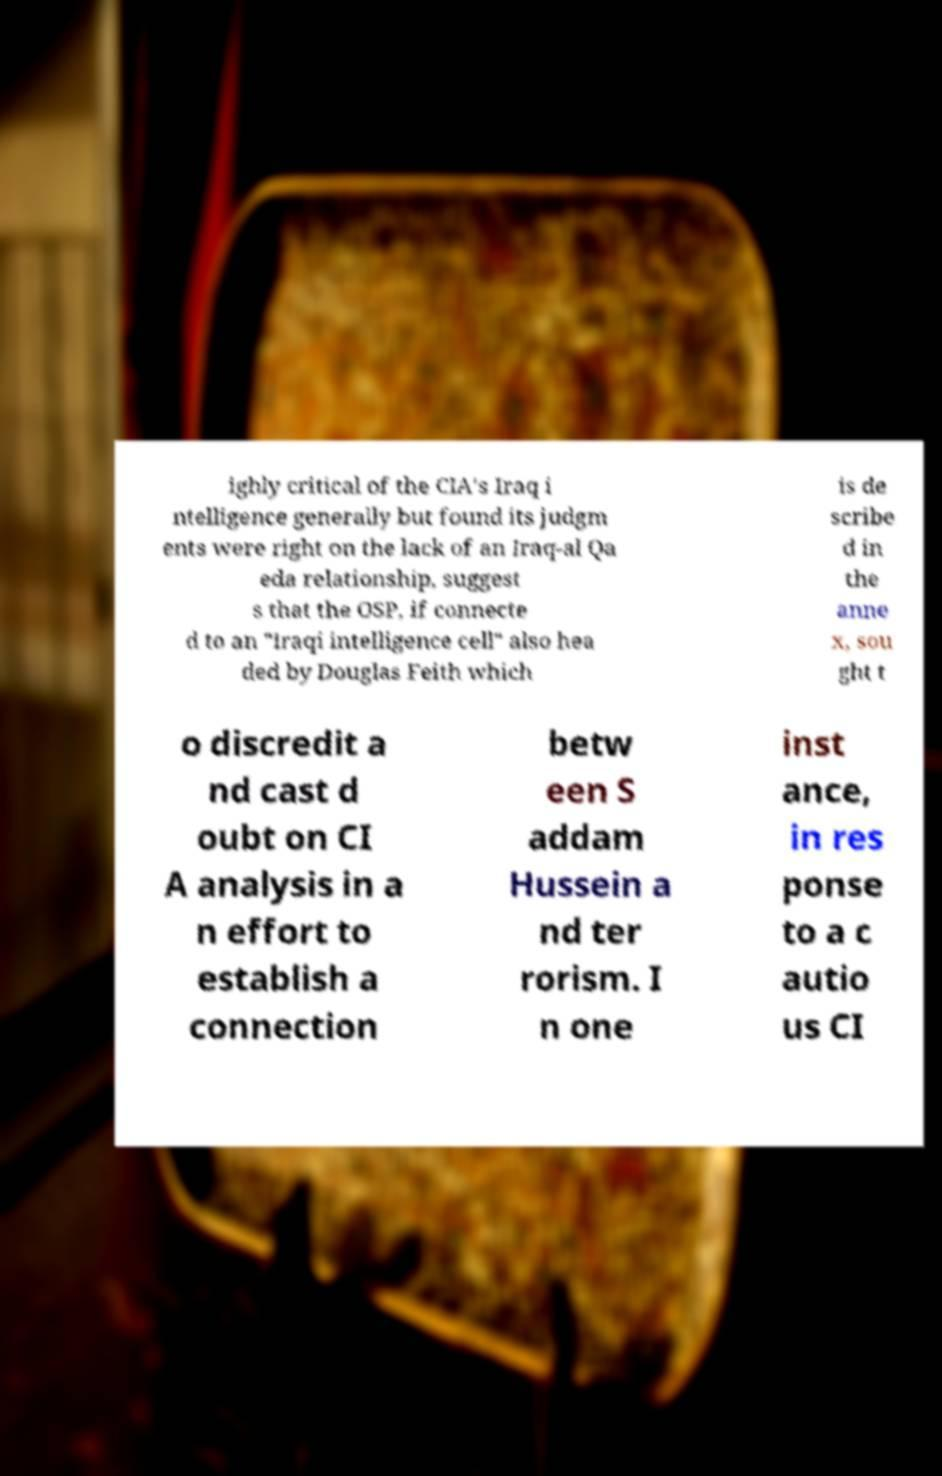Could you assist in decoding the text presented in this image and type it out clearly? ighly critical of the CIA's Iraq i ntelligence generally but found its judgm ents were right on the lack of an Iraq-al Qa eda relationship, suggest s that the OSP, if connecte d to an "Iraqi intelligence cell" also hea ded by Douglas Feith which is de scribe d in the anne x, sou ght t o discredit a nd cast d oubt on CI A analysis in a n effort to establish a connection betw een S addam Hussein a nd ter rorism. I n one inst ance, in res ponse to a c autio us CI 